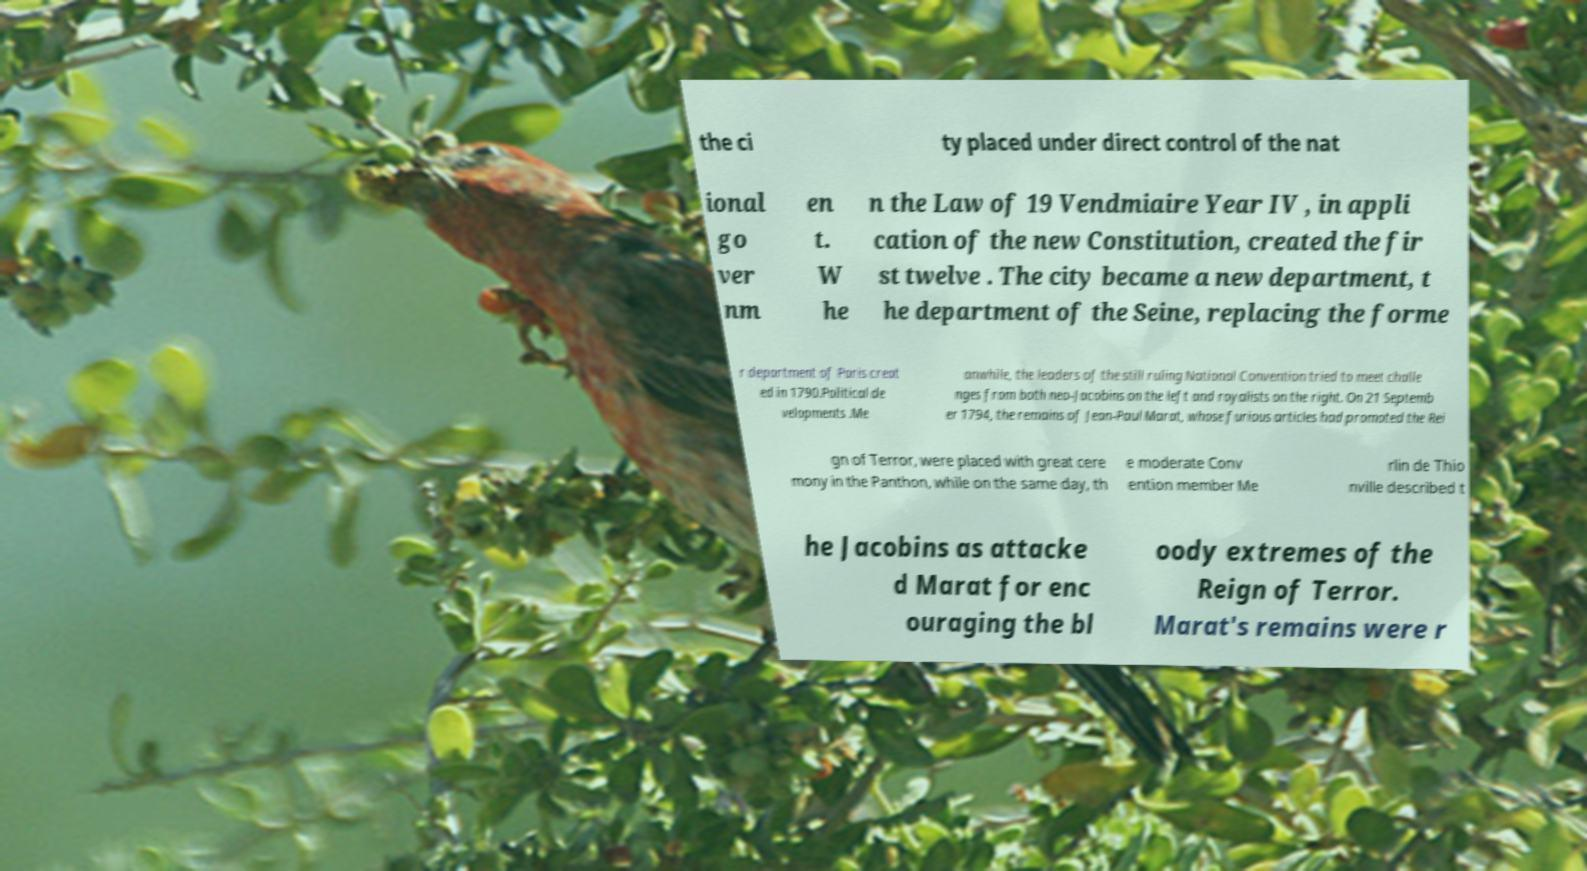I need the written content from this picture converted into text. Can you do that? the ci ty placed under direct control of the nat ional go ver nm en t. W he n the Law of 19 Vendmiaire Year IV , in appli cation of the new Constitution, created the fir st twelve . The city became a new department, t he department of the Seine, replacing the forme r department of Paris creat ed in 1790.Political de velopments .Me anwhile, the leaders of the still ruling National Convention tried to meet challe nges from both neo-Jacobins on the left and royalists on the right. On 21 Septemb er 1794, the remains of Jean-Paul Marat, whose furious articles had promoted the Rei gn of Terror, were placed with great cere mony in the Panthon, while on the same day, th e moderate Conv ention member Me rlin de Thio nville described t he Jacobins as attacke d Marat for enc ouraging the bl oody extremes of the Reign of Terror. Marat's remains were r 